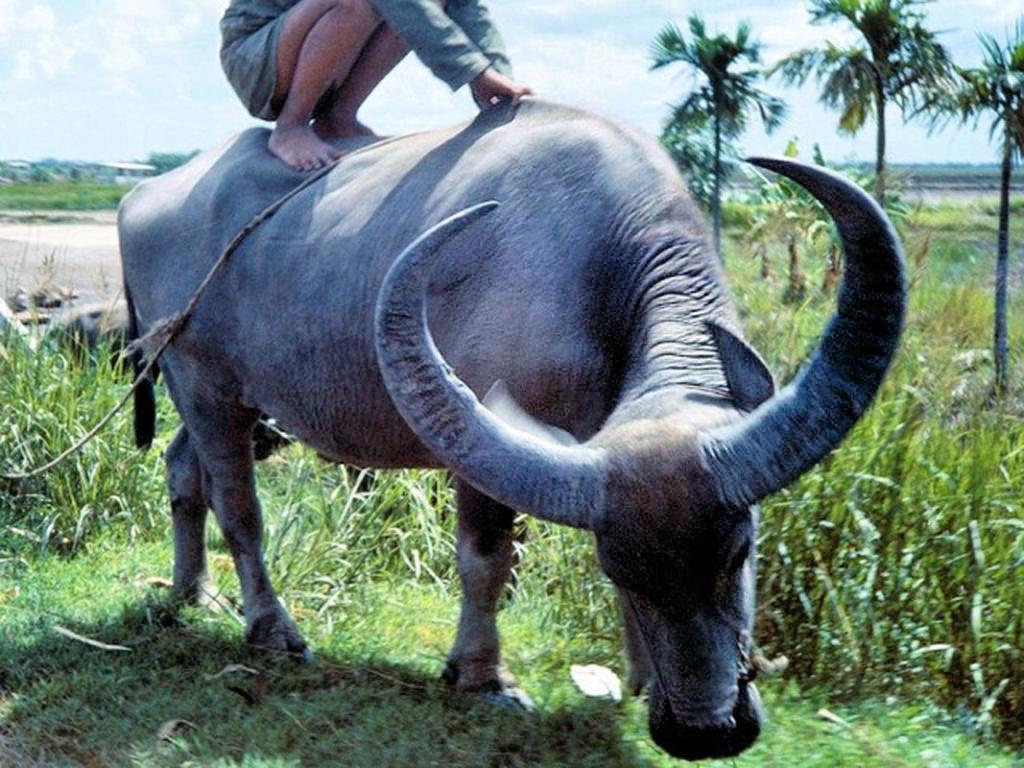In one or two sentences, can you explain what this image depicts? In front of the picture, we see a buffalo. The man in blue T-shirt is sitting on the buffalo. At the bottom of the picture, we see the grass. Behind the buffalo, We see field crops. On the right side, we see trees. There are trees and buildings in the background. At the top of the picture, we see the sky. 